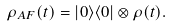<formula> <loc_0><loc_0><loc_500><loc_500>\rho _ { A F } ( t ) = | 0 \rangle \langle 0 | \otimes \rho ( t ) .</formula> 